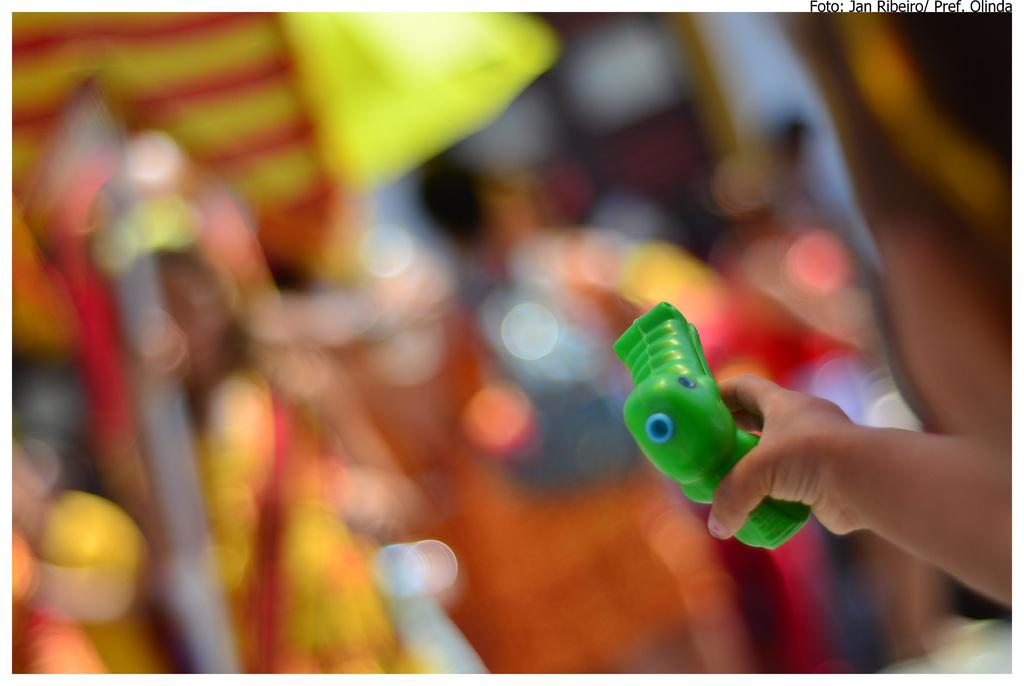What object is being held by a person in the image? There is a toy gun in the image, and it is being held by a person. What can be observed about the background of the image? The background of the image is blurred. Despite the blurred background, are there any objects visible in the background? Yes, there are objects visible in the background of the image. What type of tree is being read by the person in the image? There is no tree or reading activity present in the image; it features a person holding a toy gun with a blurred background. 